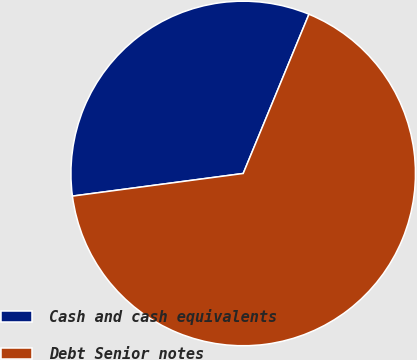<chart> <loc_0><loc_0><loc_500><loc_500><pie_chart><fcel>Cash and cash equivalents<fcel>Debt Senior notes<nl><fcel>33.33%<fcel>66.67%<nl></chart> 